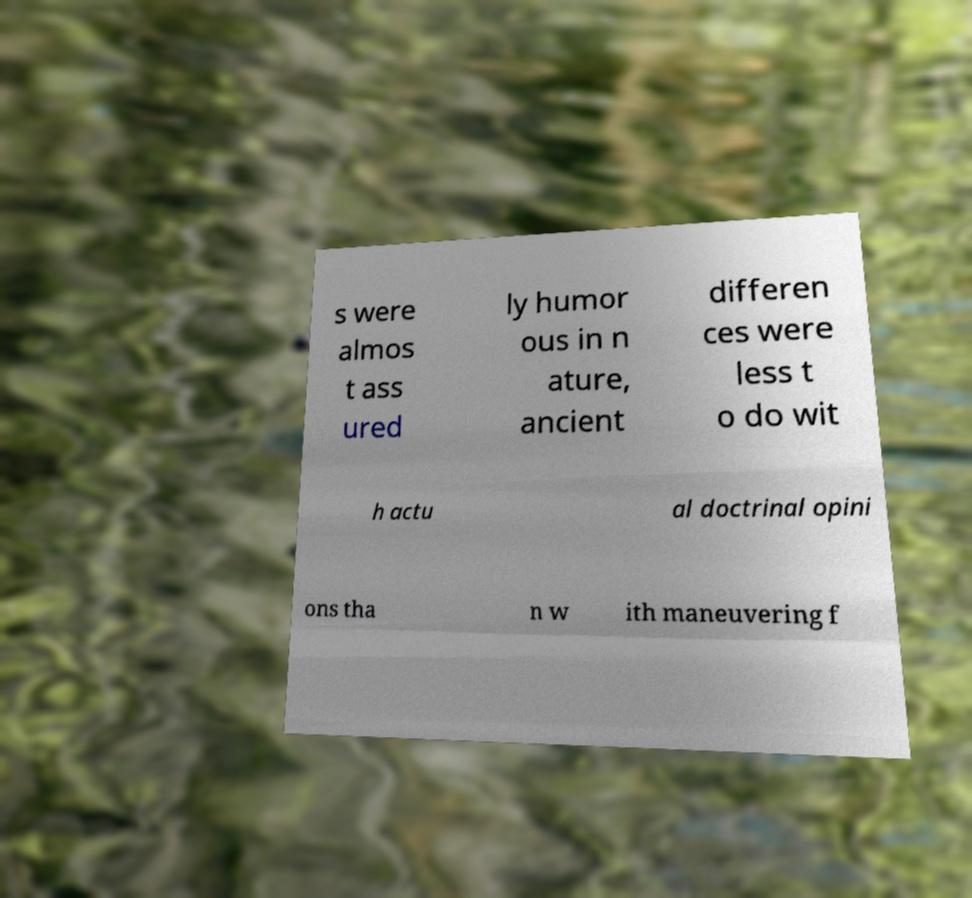What messages or text are displayed in this image? I need them in a readable, typed format. s were almos t ass ured ly humor ous in n ature, ancient differen ces were less t o do wit h actu al doctrinal opini ons tha n w ith maneuvering f 